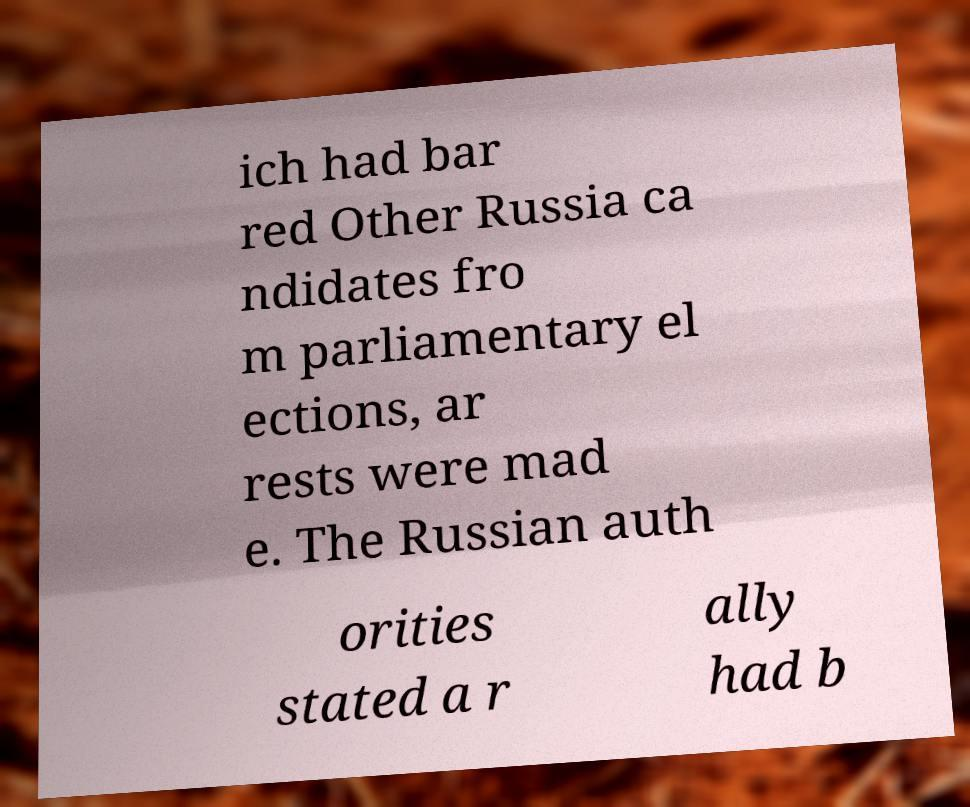There's text embedded in this image that I need extracted. Can you transcribe it verbatim? ich had bar red Other Russia ca ndidates fro m parliamentary el ections, ar rests were mad e. The Russian auth orities stated a r ally had b 